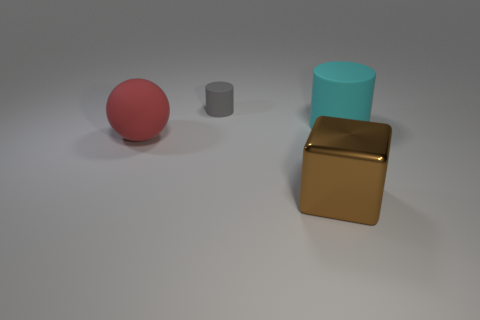Add 3 cyan rubber things. How many objects exist? 7 Subtract all balls. How many objects are left? 3 Subtract all large blue shiny cylinders. Subtract all red things. How many objects are left? 3 Add 2 small gray rubber things. How many small gray rubber things are left? 3 Add 3 cyan rubber objects. How many cyan rubber objects exist? 4 Subtract 0 red cylinders. How many objects are left? 4 